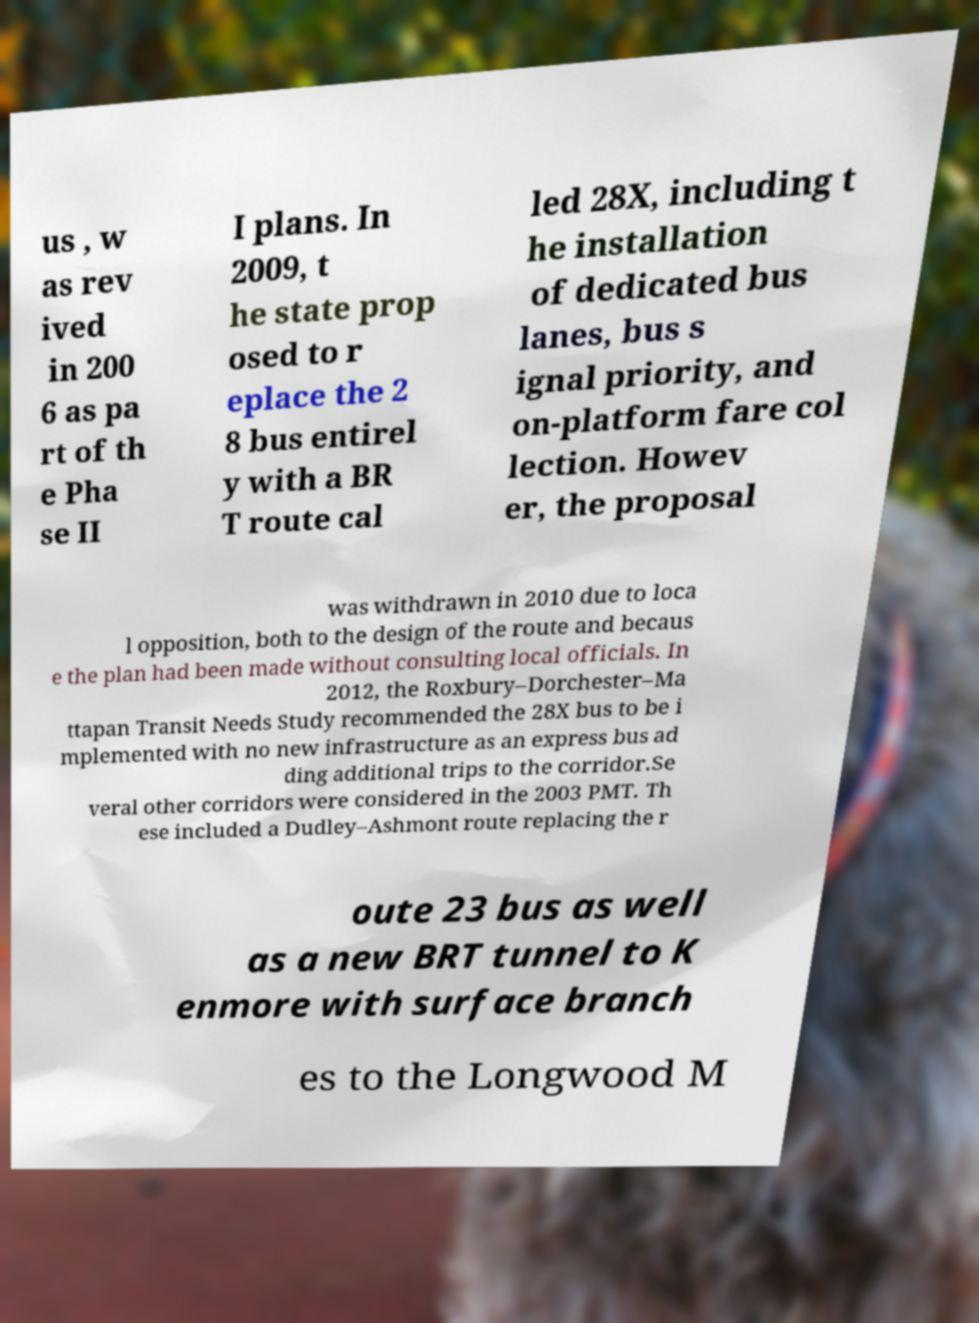Please read and relay the text visible in this image. What does it say? us , w as rev ived in 200 6 as pa rt of th e Pha se II I plans. In 2009, t he state prop osed to r eplace the 2 8 bus entirel y with a BR T route cal led 28X, including t he installation of dedicated bus lanes, bus s ignal priority, and on-platform fare col lection. Howev er, the proposal was withdrawn in 2010 due to loca l opposition, both to the design of the route and becaus e the plan had been made without consulting local officials. In 2012, the Roxbury–Dorchester–Ma ttapan Transit Needs Study recommended the 28X bus to be i mplemented with no new infrastructure as an express bus ad ding additional trips to the corridor.Se veral other corridors were considered in the 2003 PMT. Th ese included a Dudley–Ashmont route replacing the r oute 23 bus as well as a new BRT tunnel to K enmore with surface branch es to the Longwood M 